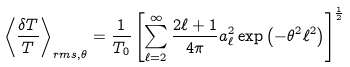<formula> <loc_0><loc_0><loc_500><loc_500>\left < \frac { \delta T } { T } \right > _ { r m s , \theta } = \frac { 1 } { T _ { 0 } } \left [ \sum _ { \ell = 2 } ^ { \infty } \frac { 2 \ell + 1 } { 4 \pi } a _ { \ell } ^ { 2 } \exp \left ( - \theta ^ { 2 } \ell ^ { 2 } \right ) \right ] ^ { \frac { 1 } { 2 } }</formula> 